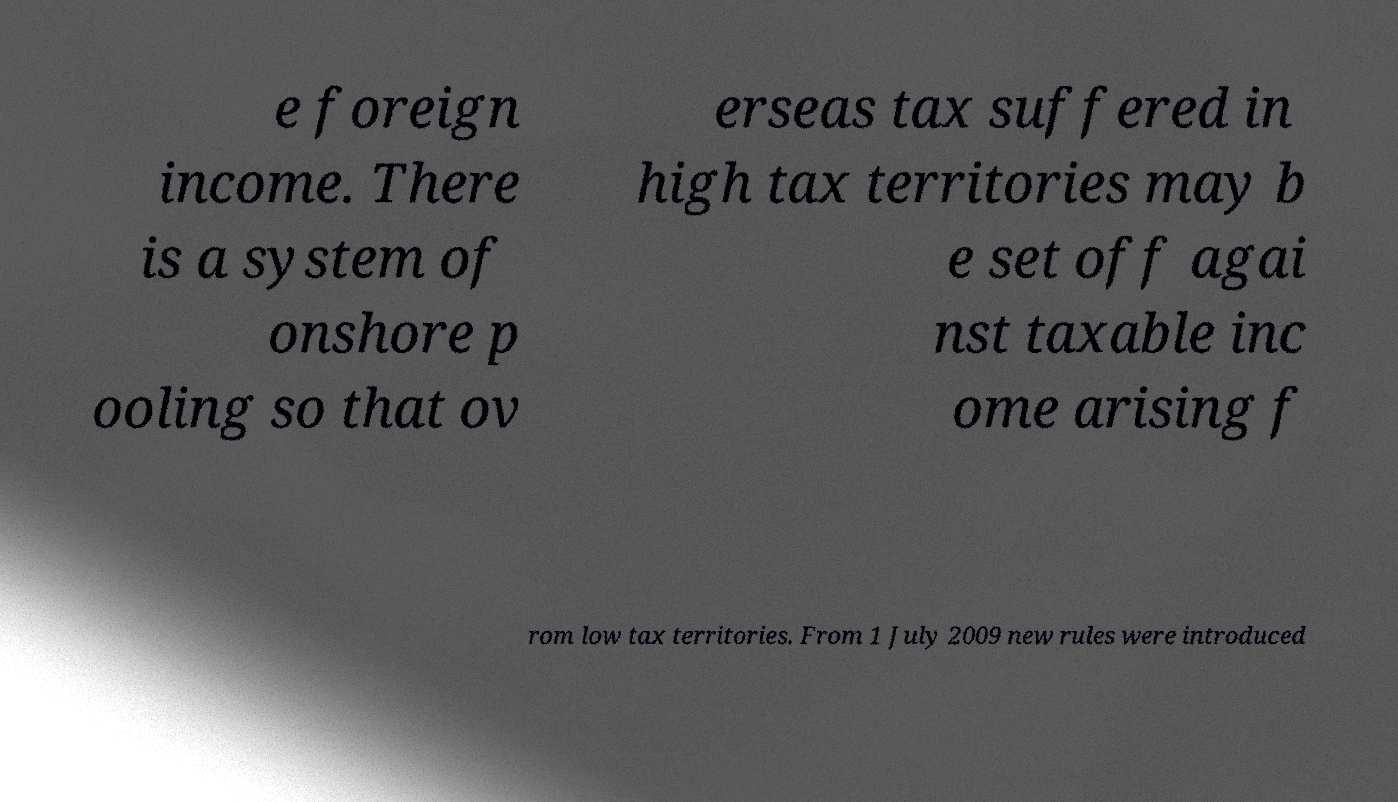Can you read and provide the text displayed in the image?This photo seems to have some interesting text. Can you extract and type it out for me? e foreign income. There is a system of onshore p ooling so that ov erseas tax suffered in high tax territories may b e set off agai nst taxable inc ome arising f rom low tax territories. From 1 July 2009 new rules were introduced 